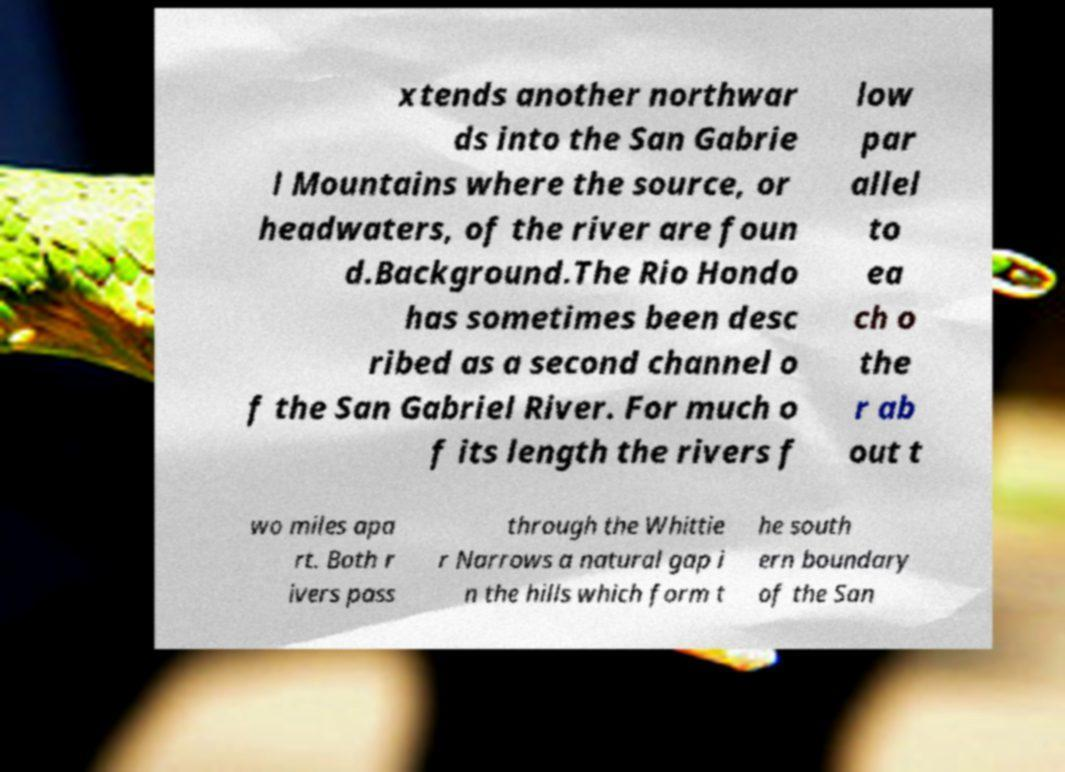Could you assist in decoding the text presented in this image and type it out clearly? xtends another northwar ds into the San Gabrie l Mountains where the source, or headwaters, of the river are foun d.Background.The Rio Hondo has sometimes been desc ribed as a second channel o f the San Gabriel River. For much o f its length the rivers f low par allel to ea ch o the r ab out t wo miles apa rt. Both r ivers pass through the Whittie r Narrows a natural gap i n the hills which form t he south ern boundary of the San 